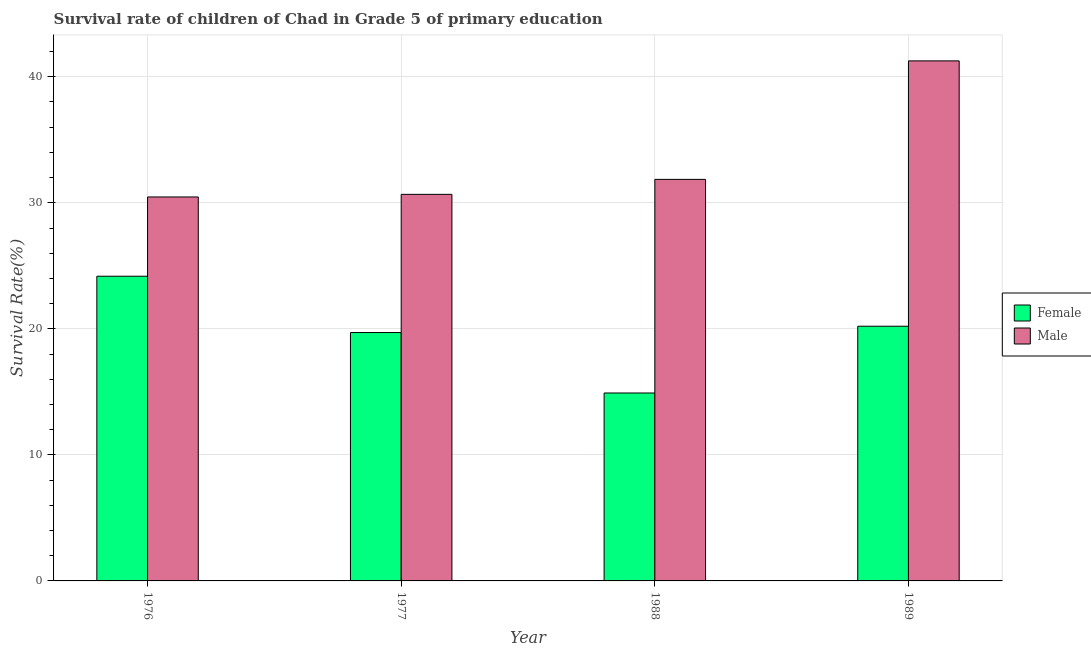How many different coloured bars are there?
Keep it short and to the point. 2. How many groups of bars are there?
Provide a short and direct response. 4. Are the number of bars per tick equal to the number of legend labels?
Offer a very short reply. Yes. How many bars are there on the 4th tick from the right?
Keep it short and to the point. 2. What is the survival rate of female students in primary education in 1976?
Provide a short and direct response. 24.17. Across all years, what is the maximum survival rate of male students in primary education?
Keep it short and to the point. 41.26. Across all years, what is the minimum survival rate of female students in primary education?
Make the answer very short. 14.91. In which year was the survival rate of female students in primary education maximum?
Your response must be concise. 1976. What is the total survival rate of female students in primary education in the graph?
Offer a very short reply. 79. What is the difference between the survival rate of female students in primary education in 1977 and that in 1989?
Offer a terse response. -0.5. What is the difference between the survival rate of male students in primary education in 1988 and the survival rate of female students in primary education in 1977?
Your response must be concise. 1.19. What is the average survival rate of male students in primary education per year?
Your answer should be compact. 33.56. In the year 1989, what is the difference between the survival rate of female students in primary education and survival rate of male students in primary education?
Make the answer very short. 0. What is the ratio of the survival rate of male students in primary education in 1988 to that in 1989?
Keep it short and to the point. 0.77. What is the difference between the highest and the second highest survival rate of male students in primary education?
Keep it short and to the point. 9.4. What is the difference between the highest and the lowest survival rate of female students in primary education?
Keep it short and to the point. 9.26. In how many years, is the survival rate of male students in primary education greater than the average survival rate of male students in primary education taken over all years?
Offer a very short reply. 1. What does the 1st bar from the right in 1977 represents?
Provide a short and direct response. Male. How many bars are there?
Your answer should be very brief. 8. How many years are there in the graph?
Offer a terse response. 4. What is the difference between two consecutive major ticks on the Y-axis?
Ensure brevity in your answer.  10. Does the graph contain any zero values?
Make the answer very short. No. Does the graph contain grids?
Provide a succinct answer. Yes. What is the title of the graph?
Offer a terse response. Survival rate of children of Chad in Grade 5 of primary education. What is the label or title of the Y-axis?
Your answer should be compact. Survival Rate(%). What is the Survival Rate(%) of Female in 1976?
Make the answer very short. 24.17. What is the Survival Rate(%) in Male in 1976?
Your response must be concise. 30.46. What is the Survival Rate(%) in Female in 1977?
Give a very brief answer. 19.71. What is the Survival Rate(%) of Male in 1977?
Ensure brevity in your answer.  30.67. What is the Survival Rate(%) of Female in 1988?
Ensure brevity in your answer.  14.91. What is the Survival Rate(%) of Male in 1988?
Your answer should be compact. 31.86. What is the Survival Rate(%) of Female in 1989?
Provide a succinct answer. 20.21. What is the Survival Rate(%) of Male in 1989?
Give a very brief answer. 41.26. Across all years, what is the maximum Survival Rate(%) in Female?
Keep it short and to the point. 24.17. Across all years, what is the maximum Survival Rate(%) in Male?
Offer a very short reply. 41.26. Across all years, what is the minimum Survival Rate(%) of Female?
Provide a succinct answer. 14.91. Across all years, what is the minimum Survival Rate(%) of Male?
Offer a very short reply. 30.46. What is the total Survival Rate(%) of Female in the graph?
Your answer should be very brief. 79. What is the total Survival Rate(%) of Male in the graph?
Keep it short and to the point. 134.25. What is the difference between the Survival Rate(%) in Female in 1976 and that in 1977?
Keep it short and to the point. 4.47. What is the difference between the Survival Rate(%) of Male in 1976 and that in 1977?
Ensure brevity in your answer.  -0.21. What is the difference between the Survival Rate(%) in Female in 1976 and that in 1988?
Ensure brevity in your answer.  9.26. What is the difference between the Survival Rate(%) in Male in 1976 and that in 1988?
Offer a very short reply. -1.39. What is the difference between the Survival Rate(%) in Female in 1976 and that in 1989?
Offer a very short reply. 3.97. What is the difference between the Survival Rate(%) of Male in 1976 and that in 1989?
Ensure brevity in your answer.  -10.8. What is the difference between the Survival Rate(%) in Female in 1977 and that in 1988?
Your answer should be compact. 4.8. What is the difference between the Survival Rate(%) of Male in 1977 and that in 1988?
Make the answer very short. -1.19. What is the difference between the Survival Rate(%) of Female in 1977 and that in 1989?
Give a very brief answer. -0.5. What is the difference between the Survival Rate(%) in Male in 1977 and that in 1989?
Your answer should be compact. -10.59. What is the difference between the Survival Rate(%) in Female in 1988 and that in 1989?
Your answer should be very brief. -5.3. What is the difference between the Survival Rate(%) of Male in 1988 and that in 1989?
Your answer should be very brief. -9.4. What is the difference between the Survival Rate(%) of Female in 1976 and the Survival Rate(%) of Male in 1977?
Provide a short and direct response. -6.5. What is the difference between the Survival Rate(%) in Female in 1976 and the Survival Rate(%) in Male in 1988?
Your response must be concise. -7.68. What is the difference between the Survival Rate(%) in Female in 1976 and the Survival Rate(%) in Male in 1989?
Make the answer very short. -17.09. What is the difference between the Survival Rate(%) of Female in 1977 and the Survival Rate(%) of Male in 1988?
Ensure brevity in your answer.  -12.15. What is the difference between the Survival Rate(%) of Female in 1977 and the Survival Rate(%) of Male in 1989?
Your answer should be very brief. -21.55. What is the difference between the Survival Rate(%) of Female in 1988 and the Survival Rate(%) of Male in 1989?
Your answer should be compact. -26.35. What is the average Survival Rate(%) in Female per year?
Keep it short and to the point. 19.75. What is the average Survival Rate(%) in Male per year?
Your response must be concise. 33.56. In the year 1976, what is the difference between the Survival Rate(%) of Female and Survival Rate(%) of Male?
Keep it short and to the point. -6.29. In the year 1977, what is the difference between the Survival Rate(%) in Female and Survival Rate(%) in Male?
Your answer should be very brief. -10.96. In the year 1988, what is the difference between the Survival Rate(%) in Female and Survival Rate(%) in Male?
Make the answer very short. -16.95. In the year 1989, what is the difference between the Survival Rate(%) in Female and Survival Rate(%) in Male?
Your answer should be compact. -21.05. What is the ratio of the Survival Rate(%) in Female in 1976 to that in 1977?
Provide a short and direct response. 1.23. What is the ratio of the Survival Rate(%) in Female in 1976 to that in 1988?
Your answer should be compact. 1.62. What is the ratio of the Survival Rate(%) in Male in 1976 to that in 1988?
Your answer should be compact. 0.96. What is the ratio of the Survival Rate(%) of Female in 1976 to that in 1989?
Offer a terse response. 1.2. What is the ratio of the Survival Rate(%) of Male in 1976 to that in 1989?
Offer a very short reply. 0.74. What is the ratio of the Survival Rate(%) of Female in 1977 to that in 1988?
Ensure brevity in your answer.  1.32. What is the ratio of the Survival Rate(%) of Male in 1977 to that in 1988?
Your answer should be very brief. 0.96. What is the ratio of the Survival Rate(%) in Female in 1977 to that in 1989?
Provide a short and direct response. 0.98. What is the ratio of the Survival Rate(%) of Male in 1977 to that in 1989?
Your response must be concise. 0.74. What is the ratio of the Survival Rate(%) of Female in 1988 to that in 1989?
Your response must be concise. 0.74. What is the ratio of the Survival Rate(%) in Male in 1988 to that in 1989?
Provide a succinct answer. 0.77. What is the difference between the highest and the second highest Survival Rate(%) of Female?
Your answer should be compact. 3.97. What is the difference between the highest and the second highest Survival Rate(%) of Male?
Keep it short and to the point. 9.4. What is the difference between the highest and the lowest Survival Rate(%) of Female?
Provide a succinct answer. 9.26. What is the difference between the highest and the lowest Survival Rate(%) of Male?
Make the answer very short. 10.8. 